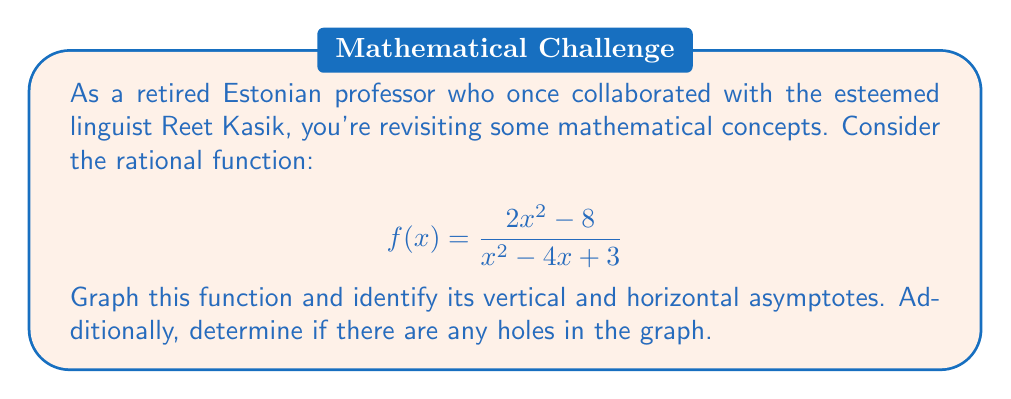Teach me how to tackle this problem. Let's approach this step-by-step:

1) First, let's identify the vertical asymptotes. These occur when the denominator equals zero:

   $x^2 - 4x + 3 = 0$
   $(x - 1)(x - 3) = 0$
   $x = 1$ or $x = 3$

   So, we have vertical asymptotes at $x = 1$ and $x = 3$.

2) For the horizontal asymptote, we compare the degrees of the numerator and denominator:

   Degree of numerator: 2
   Degree of denominator: 2

   Since they're equal, the horizontal asymptote will be the ratio of the leading coefficients:

   $y = \frac{2}{1} = 2$

3) To check for holes, we need to see if there are any common factors in the numerator and denominator:

   $\frac{2x^2 - 8}{x^2 - 4x + 3} = \frac{2(x^2 - 4)}{(x - 1)(x - 3)}$

   There are no common factors, so there are no holes in the graph.

4) To sketch the graph:
   - Plot the vertical asymptotes at $x = 1$ and $x = 3$
   - Draw the horizontal asymptote at $y = 2$
   - The function will approach positive infinity as x approaches 1 and 3 from the right
   - The function will approach negative infinity as x approaches 1 and 3 from the left
   - The graph will cross the y-axis at $y = \frac{-8}{3}$ (when $x = 0$)

[asy]
import graph;
size(200,200);
real f(real x) {return (2*x^2 - 8)/(x^2 - 4*x + 3);}
draw(graph(f,-2,0.9),blue);
draw(graph(f,1.1,2.9),blue);
draw(graph(f,3.1,6),blue);
draw((1,1)--(1,6),dashed);
draw((3,1)--(3,6),dashed);
draw((-2,2)--(6,2),dashed);
label("y=2",(-1,2),W);
label("x=1",(1,6),N);
label("x=3",(3,6),N);
xaxis("x");
yaxis("y");
[/asy]
Answer: Vertical asymptotes: $x = 1$ and $x = 3$
Horizontal asymptote: $y = 2$
No holes in the graph 